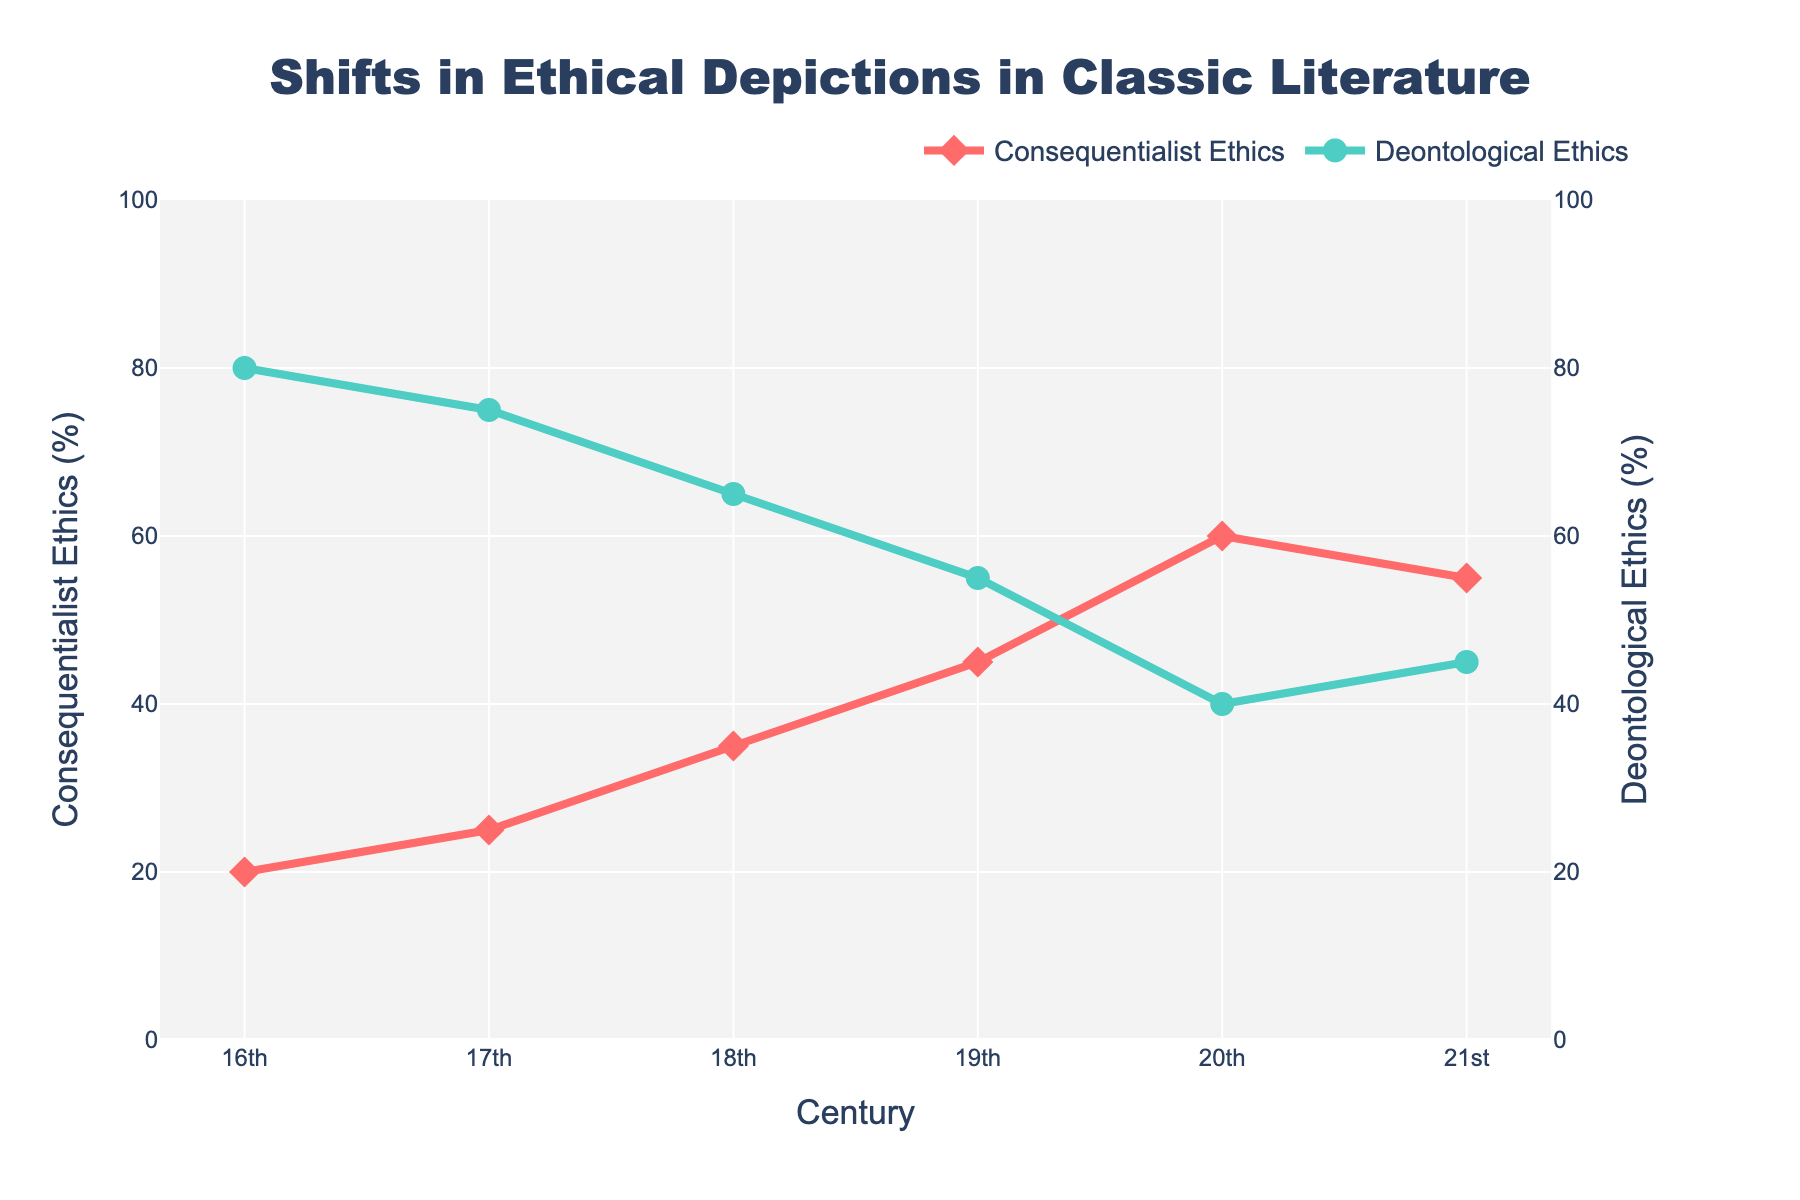What's the overall trend in the depiction of consequentialist ethics from the 16th to the 21st century? The percentage of consequentialist ethics depicted in literature has generally increased from the 16th to the 21st century. Starting at 20% in the 16th century, it peaks at 60% in the 20th century before slightly decreasing to 55% in the 21st century.
Answer: Increasing Between which centuries did the depiction of deontological ethics decrease the most significantly? Looking at the values, the largest decline occurred between the 19th and 20th centuries, where deontological ethics dropped from 55% to 40%.
Answer: 19th to 20th century How do the percentages of consequentialist and deontological ethics compare in the 20th century? In the 20th century, the percentage of consequentialist ethics is 60%, while deontological ethics is 40%. Consequentialist ethics is more prominent by 20 percentage points.
Answer: Consequentialist ethics is higher by 20% What is the combined percentage of consequentialist and deontological ethics in the 18th century? In the 18th century, consequentialist ethics is at 35% and deontological ethics is at 65%. Summing these values gives 100%.
Answer: 100% In which century do we see the highest depiction of deontological ethics? The percentage of deontological ethics is highest in the 16th century, where it is depicted at 80%.
Answer: 16th century What is the average percentage of consequentialist ethics depicted in the 21st century compared to the 16th century? The average is calculated by adding the percentages of the 16th (20%) and 21st (55%) centuries and dividing by 2, resulting in (20 + 55)/2 = 37.5%.
Answer: 37.5% Which century shows a greater balance between consequentialist and deontological ethics? The 21st century shows the smallest gap between the two ethical depictions, with 55% for consequentialist and 45% for deontological ethics, yielding a difference of 10%.
Answer: 21st century What is the difference in the percentage of consequentialist ethics between the 18th and 19th centuries? Consequentialist ethics is at 35% in the 18th century and 45% in the 19th century. The difference is 45% - 35% = 10%.
Answer: 10% By how many percentage points did the depiction of deontological ethics decrease from the 17th to the 20th century? In the 17th century, deontological ethics was depicted at 75%, which dropped to 40% by the 20th century. The decrease is 75% - 40% = 35 percentage points.
Answer: 35 percentage points Which representation, consequentialist or deontological ethics, has greater variability across the centuries? Consequentialist ethics varies from 20% to 60% (a range of 40 percentage points), while deontological ethics varies from 80% to 40% (a range of 40 percentage points). Both have the same range of variability, 40 percentage points.
Answer: Both are equal 